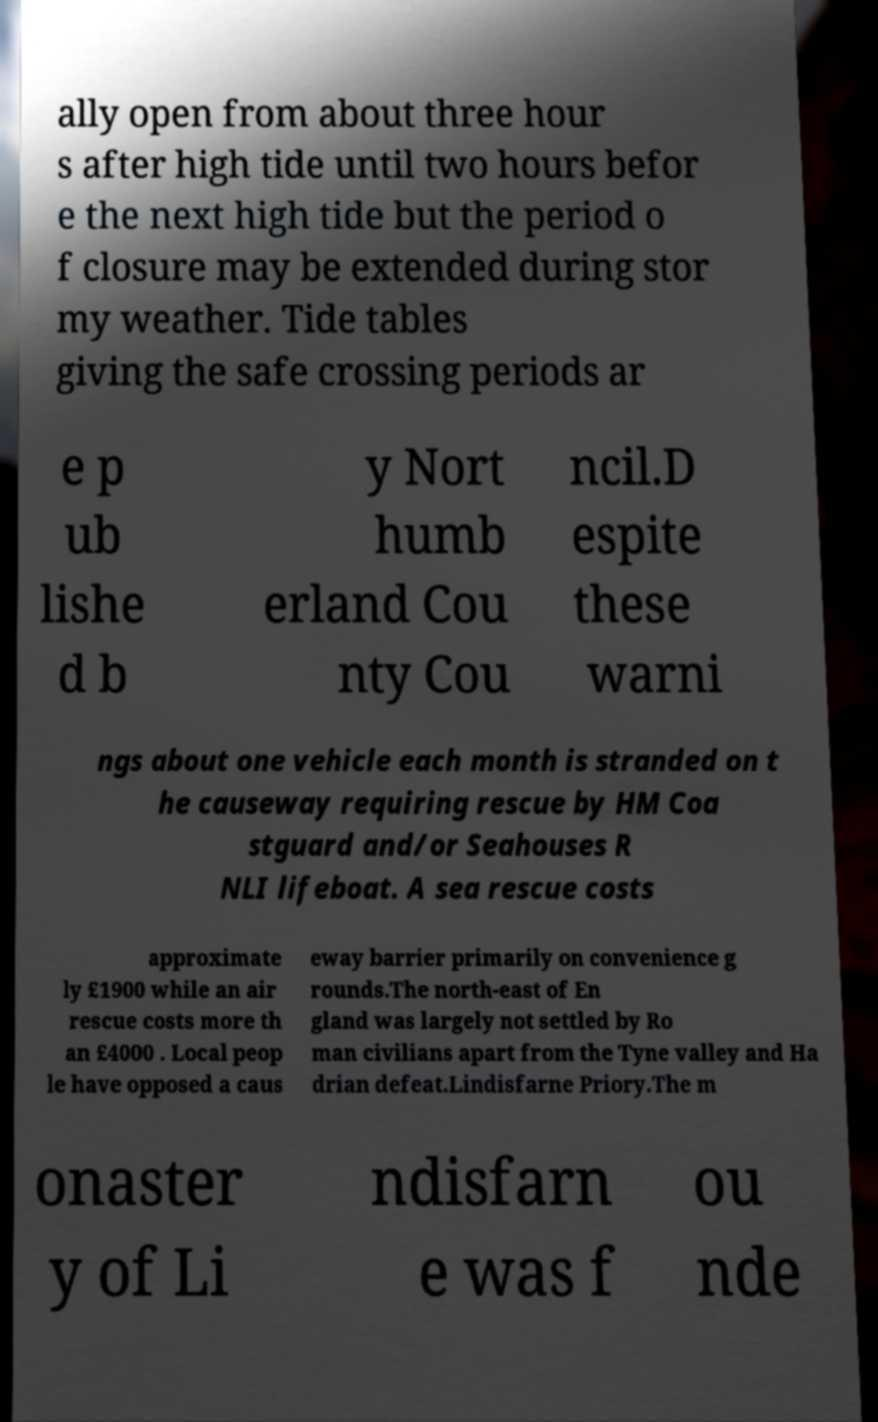Can you accurately transcribe the text from the provided image for me? ally open from about three hour s after high tide until two hours befor e the next high tide but the period o f closure may be extended during stor my weather. Tide tables giving the safe crossing periods ar e p ub lishe d b y Nort humb erland Cou nty Cou ncil.D espite these warni ngs about one vehicle each month is stranded on t he causeway requiring rescue by HM Coa stguard and/or Seahouses R NLI lifeboat. A sea rescue costs approximate ly £1900 while an air rescue costs more th an £4000 . Local peop le have opposed a caus eway barrier primarily on convenience g rounds.The north-east of En gland was largely not settled by Ro man civilians apart from the Tyne valley and Ha drian defeat.Lindisfarne Priory.The m onaster y of Li ndisfarn e was f ou nde 